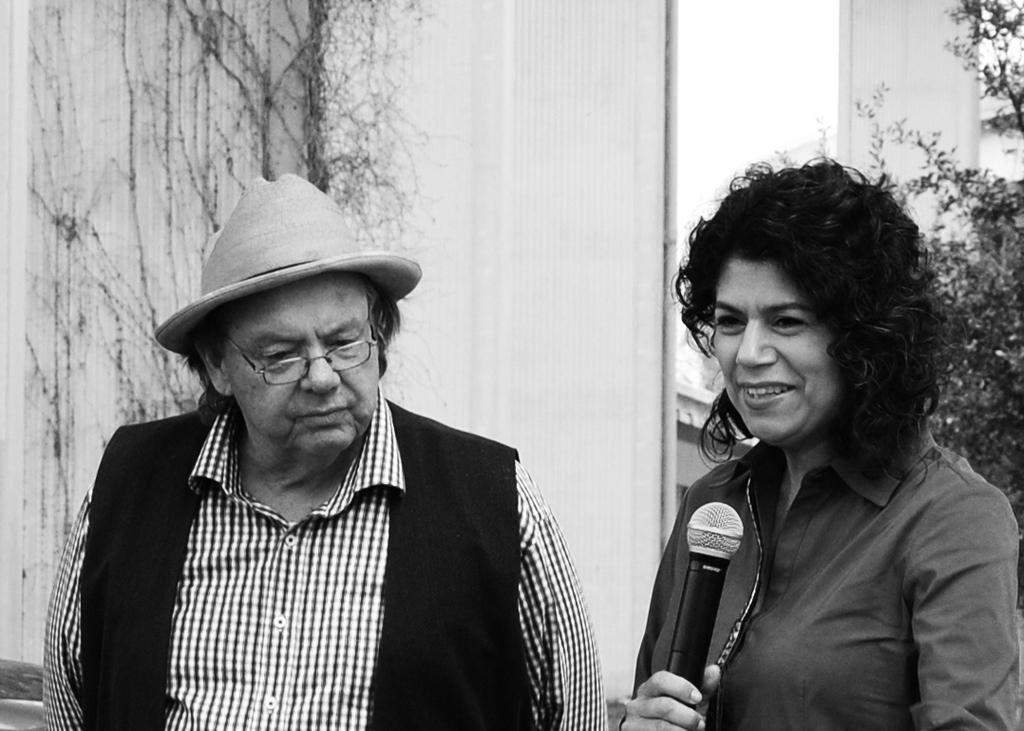Please provide a concise description of this image. In this picture we can see a man and a woman holding a mic. 